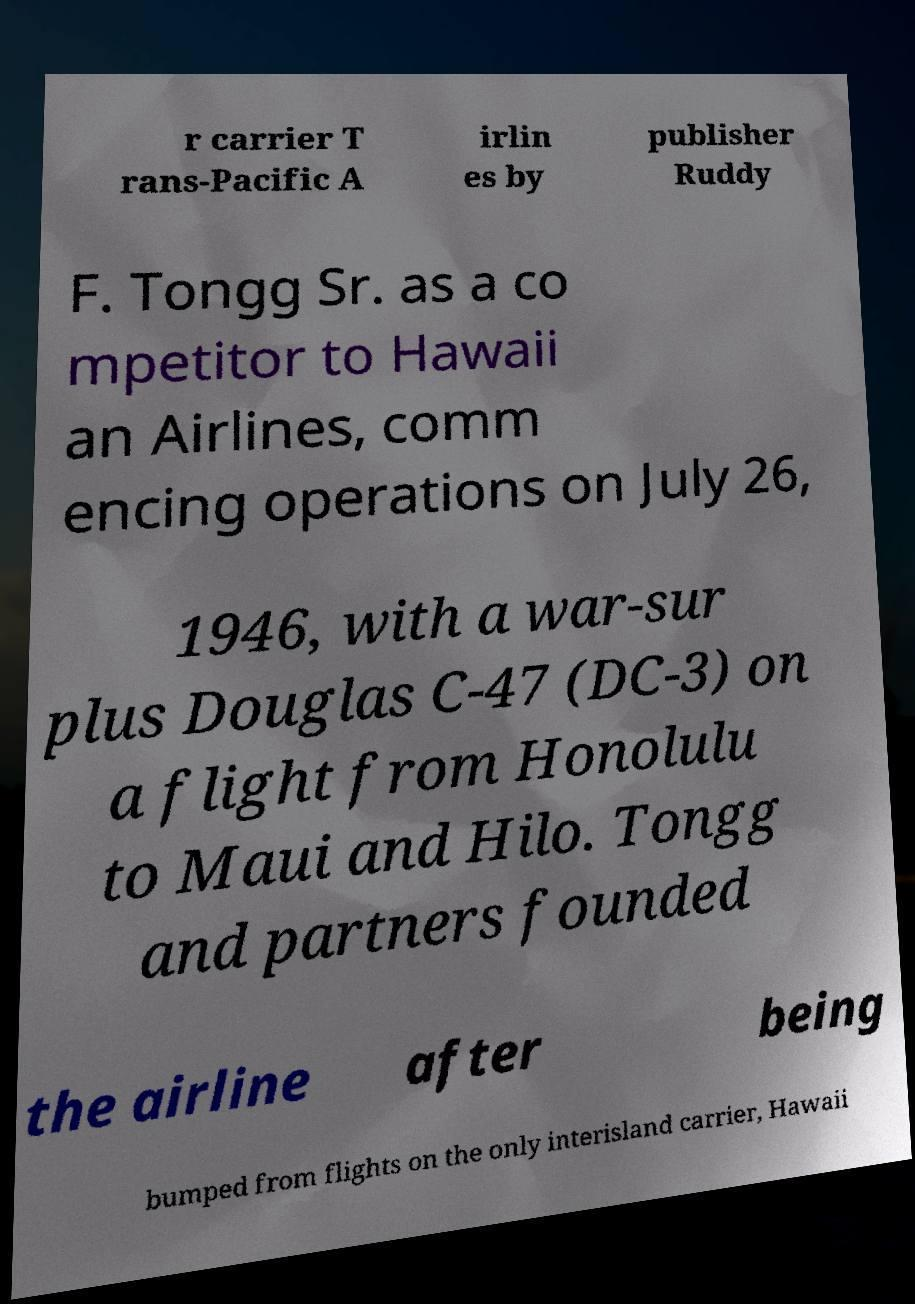Please read and relay the text visible in this image. What does it say? r carrier T rans-Pacific A irlin es by publisher Ruddy F. Tongg Sr. as a co mpetitor to Hawaii an Airlines, comm encing operations on July 26, 1946, with a war-sur plus Douglas C-47 (DC-3) on a flight from Honolulu to Maui and Hilo. Tongg and partners founded the airline after being bumped from flights on the only interisland carrier, Hawaii 